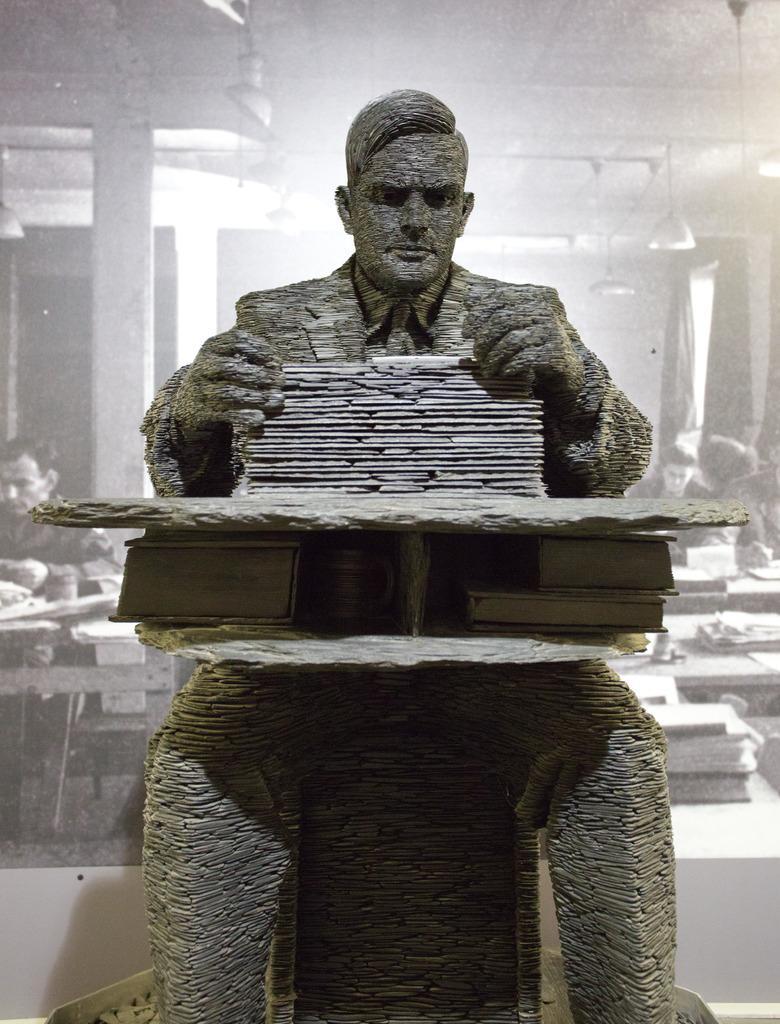Describe this image in one or two sentences. In the foreground of this image, there is a statue sitting near a table on which books are placed. In the background, it seems like a black and white screen, where a man sitting near a table is on the left and few are sitting near tables are on the right. In the background, there are lambs to the ceiling, few pillars and a wall. 